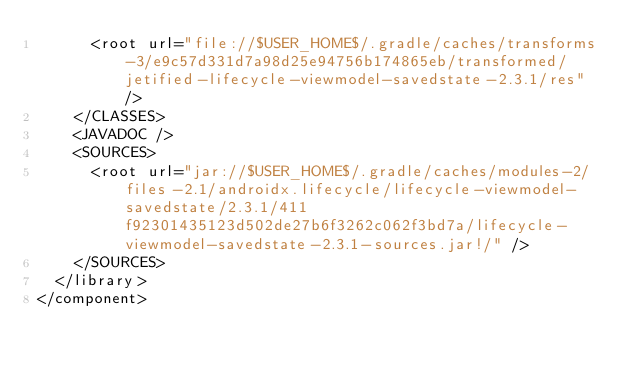Convert code to text. <code><loc_0><loc_0><loc_500><loc_500><_XML_>      <root url="file://$USER_HOME$/.gradle/caches/transforms-3/e9c57d331d7a98d25e94756b174865eb/transformed/jetified-lifecycle-viewmodel-savedstate-2.3.1/res" />
    </CLASSES>
    <JAVADOC />
    <SOURCES>
      <root url="jar://$USER_HOME$/.gradle/caches/modules-2/files-2.1/androidx.lifecycle/lifecycle-viewmodel-savedstate/2.3.1/411f92301435123d502de27b6f3262c062f3bd7a/lifecycle-viewmodel-savedstate-2.3.1-sources.jar!/" />
    </SOURCES>
  </library>
</component></code> 